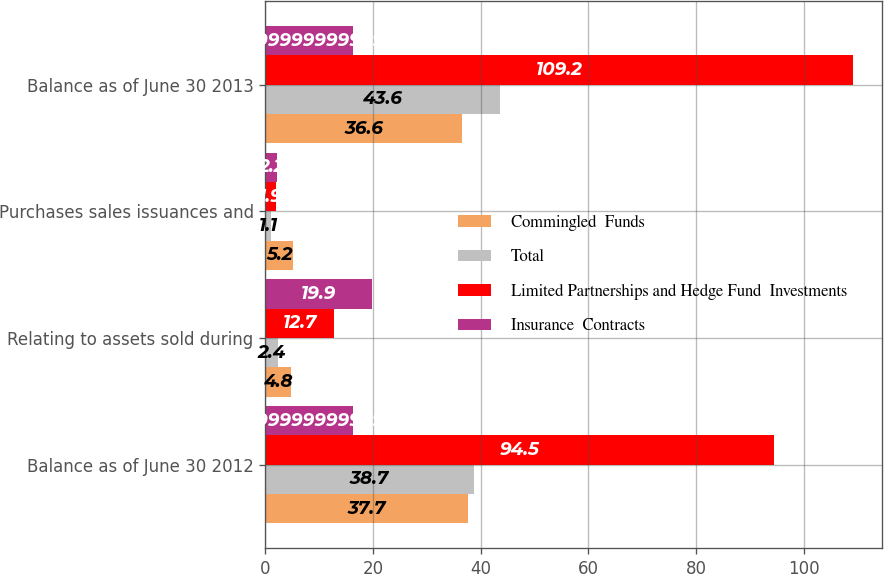<chart> <loc_0><loc_0><loc_500><loc_500><stacked_bar_chart><ecel><fcel>Balance as of June 30 2012<fcel>Relating to assets sold during<fcel>Purchases sales issuances and<fcel>Balance as of June 30 2013<nl><fcel>Commingled  Funds<fcel>37.7<fcel>4.8<fcel>5.2<fcel>36.6<nl><fcel>Total<fcel>38.7<fcel>2.4<fcel>1.1<fcel>43.6<nl><fcel>Limited Partnerships and Hedge Fund  Investments<fcel>94.5<fcel>12.7<fcel>1.9<fcel>109.2<nl><fcel>Insurance  Contracts<fcel>16.3<fcel>19.9<fcel>2.2<fcel>16.3<nl></chart> 